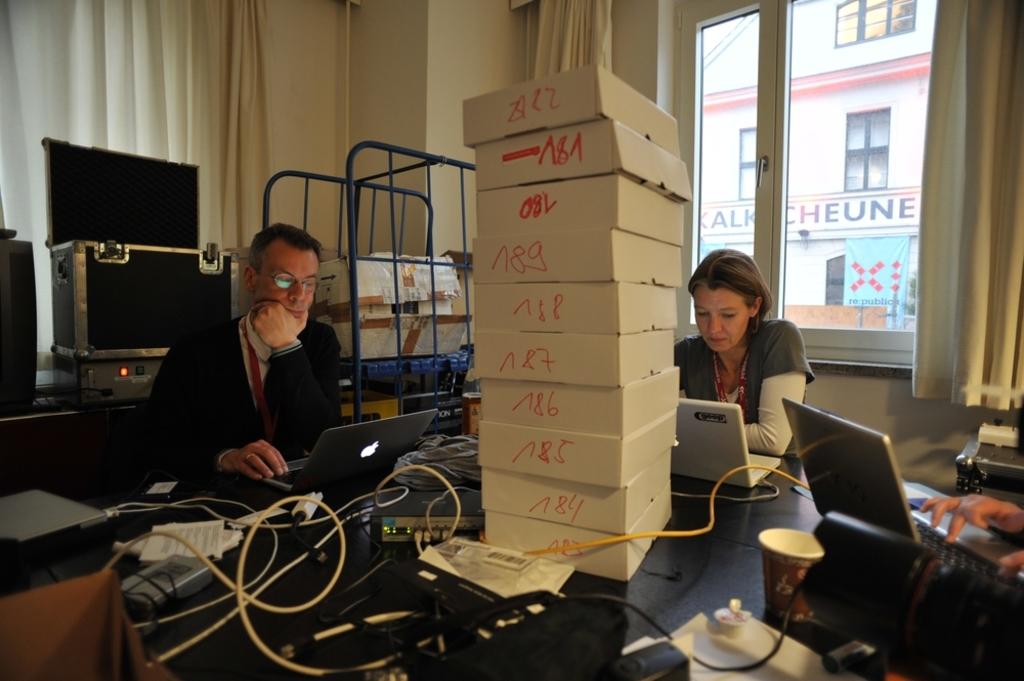What number is written on the top box?
Offer a very short reply. 22. Which box is a84?
Give a very brief answer. 9. 